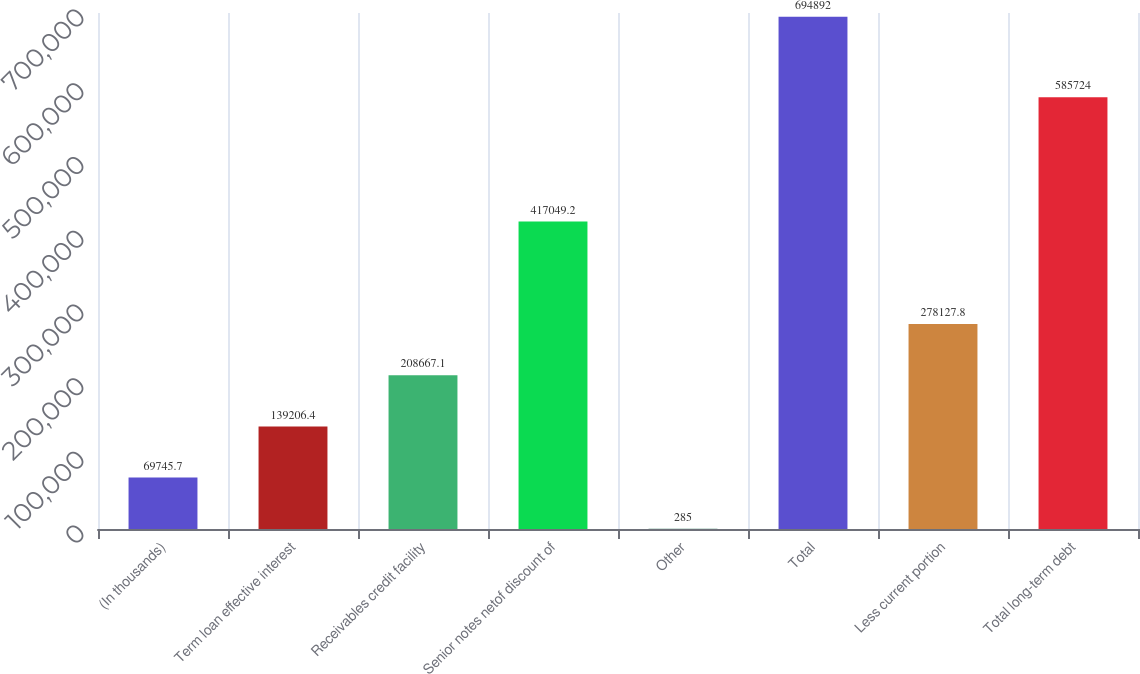<chart> <loc_0><loc_0><loc_500><loc_500><bar_chart><fcel>(In thousands)<fcel>Term loan effective interest<fcel>Receivables credit facility<fcel>Senior notes netof discount of<fcel>Other<fcel>Total<fcel>Less current portion<fcel>Total long-term debt<nl><fcel>69745.7<fcel>139206<fcel>208667<fcel>417049<fcel>285<fcel>694892<fcel>278128<fcel>585724<nl></chart> 